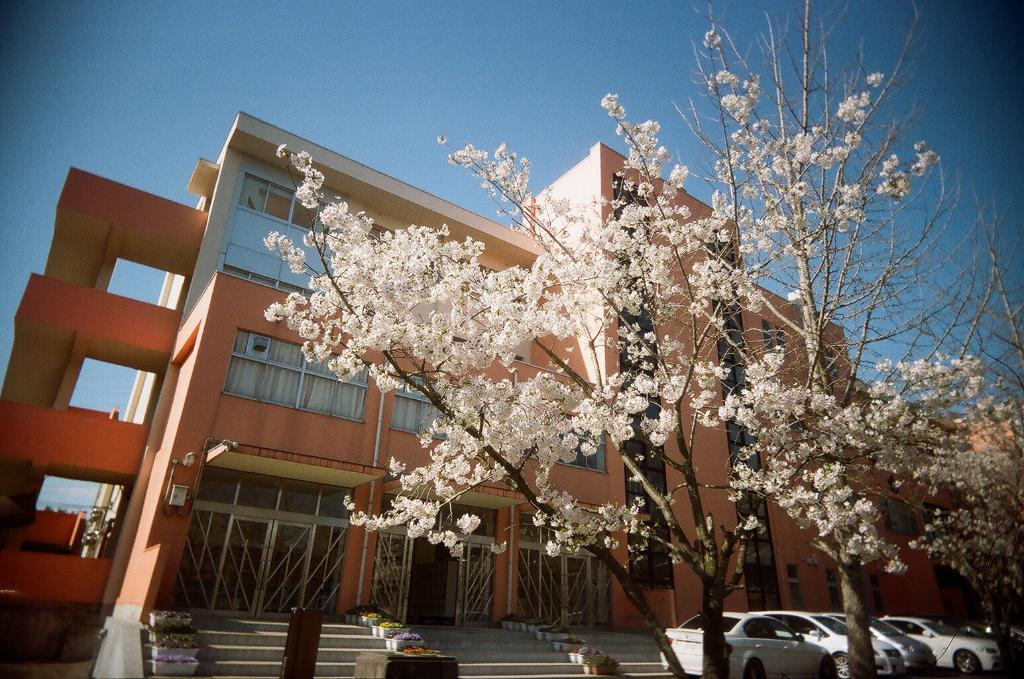What type of natural elements can be seen in the image? There are trees in the image. What man-made objects are present in the image? Cars are parked in the image, and there is a building in the image. Are there any architectural features in the image? Yes, there are stairs in the image. What is the color of the sky in the background of the image? The sky is blue in the background of the image. What type of space can be seen in the image? There is no space in the image; it features a terrestrial scene with trees, cars, stairs, a building, and a blue sky. What level of the building is shown in the image? The image does not show a specific level of the building; it only shows the exterior of the building. 